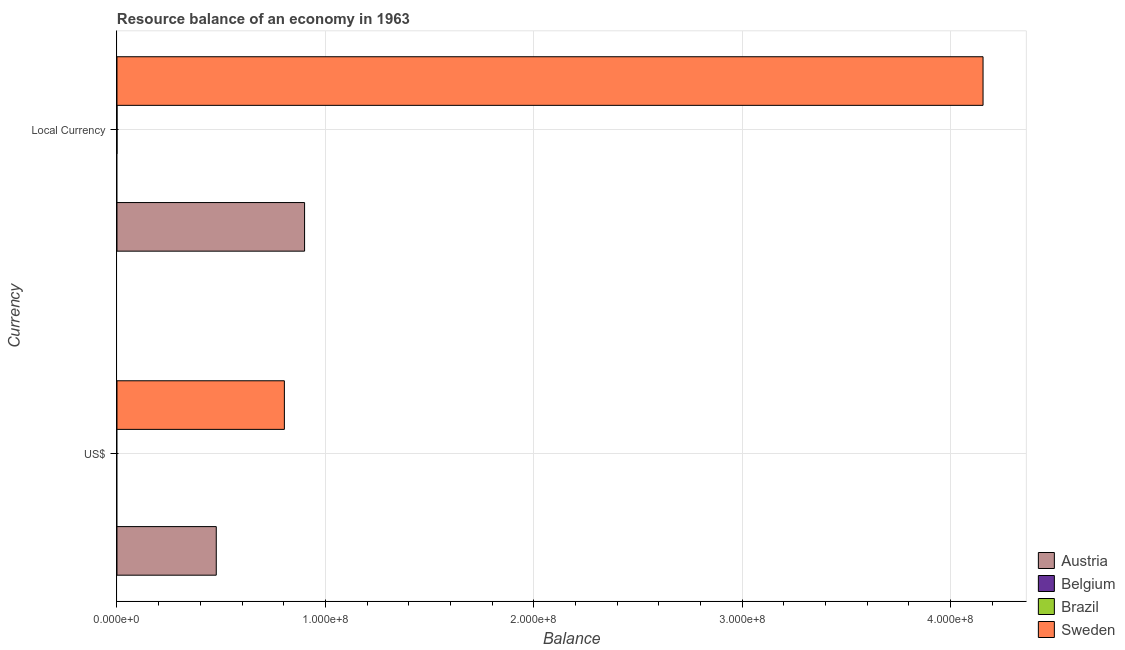How many groups of bars are there?
Give a very brief answer. 2. Are the number of bars per tick equal to the number of legend labels?
Your answer should be very brief. No. What is the label of the 1st group of bars from the top?
Provide a succinct answer. Local Currency. Across all countries, what is the maximum resource balance in us$?
Provide a succinct answer. 8.03e+07. In which country was the resource balance in constant us$ maximum?
Your response must be concise. Sweden. What is the total resource balance in us$ in the graph?
Make the answer very short. 1.28e+08. What is the difference between the resource balance in us$ in Brazil and the resource balance in constant us$ in Belgium?
Ensure brevity in your answer.  0. What is the average resource balance in us$ per country?
Provide a succinct answer. 3.20e+07. What is the difference between the resource balance in constant us$ and resource balance in us$ in Austria?
Give a very brief answer. 4.24e+07. What is the ratio of the resource balance in us$ in Sweden to that in Austria?
Offer a very short reply. 1.69. How many bars are there?
Keep it short and to the point. 4. How many countries are there in the graph?
Keep it short and to the point. 4. Are the values on the major ticks of X-axis written in scientific E-notation?
Your answer should be very brief. Yes. Does the graph contain any zero values?
Provide a succinct answer. Yes. How many legend labels are there?
Offer a very short reply. 4. How are the legend labels stacked?
Ensure brevity in your answer.  Vertical. What is the title of the graph?
Make the answer very short. Resource balance of an economy in 1963. Does "Samoa" appear as one of the legend labels in the graph?
Offer a very short reply. No. What is the label or title of the X-axis?
Provide a succinct answer. Balance. What is the label or title of the Y-axis?
Give a very brief answer. Currency. What is the Balance in Austria in US$?
Your response must be concise. 4.76e+07. What is the Balance of Sweden in US$?
Offer a very short reply. 8.03e+07. What is the Balance in Austria in Local Currency?
Make the answer very short. 9.00e+07. What is the Balance in Sweden in Local Currency?
Offer a terse response. 4.16e+08. Across all Currency, what is the maximum Balance of Austria?
Your answer should be very brief. 9.00e+07. Across all Currency, what is the maximum Balance in Sweden?
Keep it short and to the point. 4.16e+08. Across all Currency, what is the minimum Balance in Austria?
Keep it short and to the point. 4.76e+07. Across all Currency, what is the minimum Balance of Sweden?
Keep it short and to the point. 8.03e+07. What is the total Balance of Austria in the graph?
Provide a succinct answer. 1.38e+08. What is the total Balance in Belgium in the graph?
Offer a very short reply. 0. What is the total Balance in Sweden in the graph?
Your response must be concise. 4.96e+08. What is the difference between the Balance in Austria in US$ and that in Local Currency?
Provide a short and direct response. -4.24e+07. What is the difference between the Balance in Sweden in US$ and that in Local Currency?
Your answer should be very brief. -3.35e+08. What is the difference between the Balance in Austria in US$ and the Balance in Sweden in Local Currency?
Offer a very short reply. -3.68e+08. What is the average Balance of Austria per Currency?
Provide a short and direct response. 6.88e+07. What is the average Balance in Belgium per Currency?
Keep it short and to the point. 0. What is the average Balance in Brazil per Currency?
Offer a very short reply. 0. What is the average Balance in Sweden per Currency?
Offer a terse response. 2.48e+08. What is the difference between the Balance in Austria and Balance in Sweden in US$?
Ensure brevity in your answer.  -3.27e+07. What is the difference between the Balance of Austria and Balance of Sweden in Local Currency?
Offer a terse response. -3.26e+08. What is the ratio of the Balance of Austria in US$ to that in Local Currency?
Ensure brevity in your answer.  0.53. What is the ratio of the Balance of Sweden in US$ to that in Local Currency?
Make the answer very short. 0.19. What is the difference between the highest and the second highest Balance of Austria?
Give a very brief answer. 4.24e+07. What is the difference between the highest and the second highest Balance in Sweden?
Your answer should be very brief. 3.35e+08. What is the difference between the highest and the lowest Balance in Austria?
Give a very brief answer. 4.24e+07. What is the difference between the highest and the lowest Balance in Sweden?
Provide a succinct answer. 3.35e+08. 